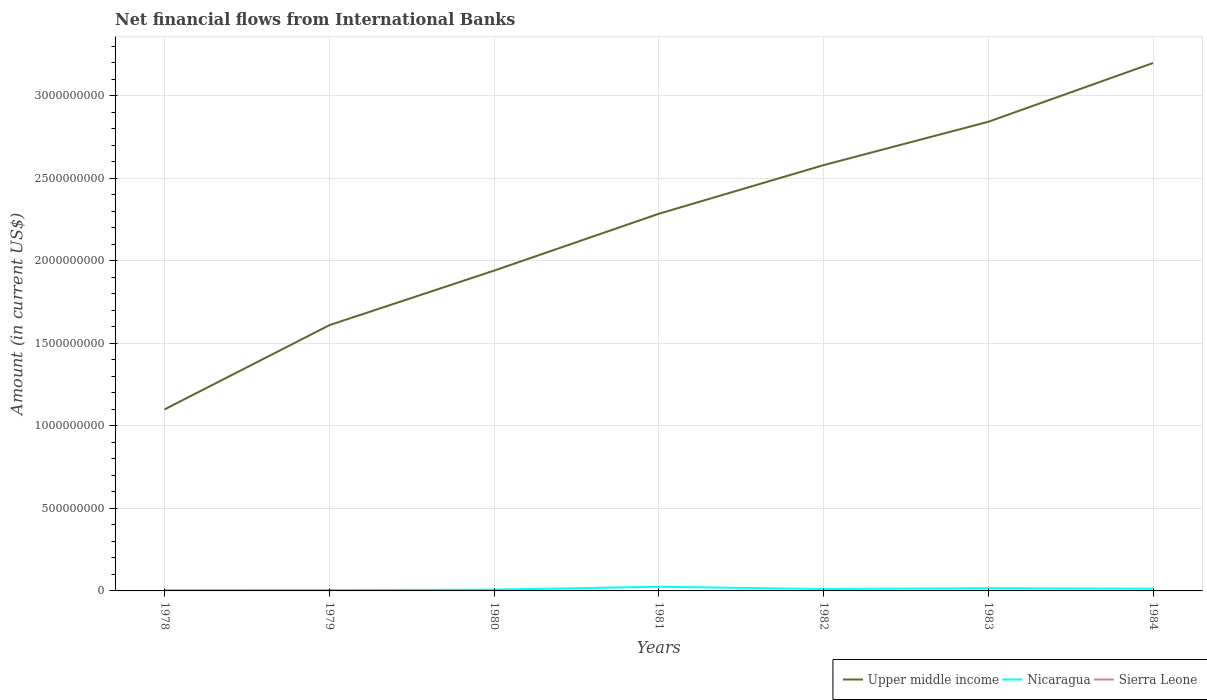Does the line corresponding to Nicaragua intersect with the line corresponding to Sierra Leone?
Make the answer very short. No. Across all years, what is the maximum net financial aid flows in Upper middle income?
Offer a very short reply. 1.10e+09. What is the total net financial aid flows in Upper middle income in the graph?
Give a very brief answer. -1.59e+09. What is the difference between the highest and the second highest net financial aid flows in Upper middle income?
Your response must be concise. 2.10e+09. Is the net financial aid flows in Sierra Leone strictly greater than the net financial aid flows in Nicaragua over the years?
Your answer should be compact. Yes. How many lines are there?
Your answer should be compact. 3. What is the difference between two consecutive major ticks on the Y-axis?
Offer a very short reply. 5.00e+08. Does the graph contain grids?
Offer a terse response. Yes. Where does the legend appear in the graph?
Give a very brief answer. Bottom right. How many legend labels are there?
Provide a succinct answer. 3. How are the legend labels stacked?
Offer a very short reply. Horizontal. What is the title of the graph?
Your answer should be compact. Net financial flows from International Banks. What is the Amount (in current US$) of Upper middle income in 1978?
Provide a succinct answer. 1.10e+09. What is the Amount (in current US$) in Nicaragua in 1978?
Keep it short and to the point. 5.04e+06. What is the Amount (in current US$) of Sierra Leone in 1978?
Provide a short and direct response. 0. What is the Amount (in current US$) of Upper middle income in 1979?
Offer a terse response. 1.61e+09. What is the Amount (in current US$) of Nicaragua in 1979?
Make the answer very short. 4.35e+06. What is the Amount (in current US$) of Sierra Leone in 1979?
Your answer should be very brief. 2.85e+06. What is the Amount (in current US$) of Upper middle income in 1980?
Provide a succinct answer. 1.94e+09. What is the Amount (in current US$) of Nicaragua in 1980?
Keep it short and to the point. 7.92e+06. What is the Amount (in current US$) in Sierra Leone in 1980?
Your answer should be compact. 1.50e+06. What is the Amount (in current US$) in Upper middle income in 1981?
Your answer should be compact. 2.29e+09. What is the Amount (in current US$) in Nicaragua in 1981?
Your response must be concise. 2.52e+07. What is the Amount (in current US$) of Sierra Leone in 1981?
Make the answer very short. 0. What is the Amount (in current US$) in Upper middle income in 1982?
Offer a terse response. 2.58e+09. What is the Amount (in current US$) of Nicaragua in 1982?
Offer a terse response. 1.16e+07. What is the Amount (in current US$) of Upper middle income in 1983?
Your answer should be very brief. 2.84e+09. What is the Amount (in current US$) in Nicaragua in 1983?
Offer a terse response. 1.66e+07. What is the Amount (in current US$) in Sierra Leone in 1983?
Ensure brevity in your answer.  0. What is the Amount (in current US$) of Upper middle income in 1984?
Provide a short and direct response. 3.20e+09. What is the Amount (in current US$) in Nicaragua in 1984?
Make the answer very short. 1.36e+07. Across all years, what is the maximum Amount (in current US$) in Upper middle income?
Make the answer very short. 3.20e+09. Across all years, what is the maximum Amount (in current US$) of Nicaragua?
Offer a very short reply. 2.52e+07. Across all years, what is the maximum Amount (in current US$) in Sierra Leone?
Offer a terse response. 2.85e+06. Across all years, what is the minimum Amount (in current US$) in Upper middle income?
Provide a succinct answer. 1.10e+09. Across all years, what is the minimum Amount (in current US$) of Nicaragua?
Provide a short and direct response. 4.35e+06. What is the total Amount (in current US$) of Upper middle income in the graph?
Make the answer very short. 1.56e+1. What is the total Amount (in current US$) in Nicaragua in the graph?
Your answer should be compact. 8.43e+07. What is the total Amount (in current US$) in Sierra Leone in the graph?
Your answer should be compact. 4.35e+06. What is the difference between the Amount (in current US$) in Upper middle income in 1978 and that in 1979?
Keep it short and to the point. -5.10e+08. What is the difference between the Amount (in current US$) of Nicaragua in 1978 and that in 1979?
Provide a succinct answer. 6.92e+05. What is the difference between the Amount (in current US$) of Upper middle income in 1978 and that in 1980?
Your response must be concise. -8.41e+08. What is the difference between the Amount (in current US$) in Nicaragua in 1978 and that in 1980?
Make the answer very short. -2.87e+06. What is the difference between the Amount (in current US$) of Upper middle income in 1978 and that in 1981?
Ensure brevity in your answer.  -1.19e+09. What is the difference between the Amount (in current US$) of Nicaragua in 1978 and that in 1981?
Your answer should be very brief. -2.01e+07. What is the difference between the Amount (in current US$) of Upper middle income in 1978 and that in 1982?
Offer a terse response. -1.48e+09. What is the difference between the Amount (in current US$) in Nicaragua in 1978 and that in 1982?
Your answer should be very brief. -6.56e+06. What is the difference between the Amount (in current US$) of Upper middle income in 1978 and that in 1983?
Give a very brief answer. -1.74e+09. What is the difference between the Amount (in current US$) in Nicaragua in 1978 and that in 1983?
Give a very brief answer. -1.16e+07. What is the difference between the Amount (in current US$) in Upper middle income in 1978 and that in 1984?
Ensure brevity in your answer.  -2.10e+09. What is the difference between the Amount (in current US$) of Nicaragua in 1978 and that in 1984?
Offer a terse response. -8.55e+06. What is the difference between the Amount (in current US$) of Upper middle income in 1979 and that in 1980?
Provide a short and direct response. -3.31e+08. What is the difference between the Amount (in current US$) in Nicaragua in 1979 and that in 1980?
Your response must be concise. -3.57e+06. What is the difference between the Amount (in current US$) of Sierra Leone in 1979 and that in 1980?
Ensure brevity in your answer.  1.35e+06. What is the difference between the Amount (in current US$) in Upper middle income in 1979 and that in 1981?
Your response must be concise. -6.75e+08. What is the difference between the Amount (in current US$) in Nicaragua in 1979 and that in 1981?
Provide a short and direct response. -2.08e+07. What is the difference between the Amount (in current US$) of Upper middle income in 1979 and that in 1982?
Give a very brief answer. -9.70e+08. What is the difference between the Amount (in current US$) in Nicaragua in 1979 and that in 1982?
Give a very brief answer. -7.26e+06. What is the difference between the Amount (in current US$) of Upper middle income in 1979 and that in 1983?
Keep it short and to the point. -1.23e+09. What is the difference between the Amount (in current US$) in Nicaragua in 1979 and that in 1983?
Provide a short and direct response. -1.23e+07. What is the difference between the Amount (in current US$) of Upper middle income in 1979 and that in 1984?
Provide a short and direct response. -1.59e+09. What is the difference between the Amount (in current US$) in Nicaragua in 1979 and that in 1984?
Keep it short and to the point. -9.24e+06. What is the difference between the Amount (in current US$) in Upper middle income in 1980 and that in 1981?
Ensure brevity in your answer.  -3.45e+08. What is the difference between the Amount (in current US$) of Nicaragua in 1980 and that in 1981?
Offer a terse response. -1.72e+07. What is the difference between the Amount (in current US$) of Upper middle income in 1980 and that in 1982?
Ensure brevity in your answer.  -6.39e+08. What is the difference between the Amount (in current US$) in Nicaragua in 1980 and that in 1982?
Your response must be concise. -3.69e+06. What is the difference between the Amount (in current US$) of Upper middle income in 1980 and that in 1983?
Keep it short and to the point. -9.02e+08. What is the difference between the Amount (in current US$) of Nicaragua in 1980 and that in 1983?
Your answer should be compact. -8.73e+06. What is the difference between the Amount (in current US$) of Upper middle income in 1980 and that in 1984?
Provide a short and direct response. -1.26e+09. What is the difference between the Amount (in current US$) in Nicaragua in 1980 and that in 1984?
Make the answer very short. -5.67e+06. What is the difference between the Amount (in current US$) in Upper middle income in 1981 and that in 1982?
Offer a terse response. -2.95e+08. What is the difference between the Amount (in current US$) in Nicaragua in 1981 and that in 1982?
Offer a terse response. 1.35e+07. What is the difference between the Amount (in current US$) in Upper middle income in 1981 and that in 1983?
Keep it short and to the point. -5.57e+08. What is the difference between the Amount (in current US$) in Nicaragua in 1981 and that in 1983?
Provide a short and direct response. 8.51e+06. What is the difference between the Amount (in current US$) of Upper middle income in 1981 and that in 1984?
Provide a short and direct response. -9.14e+08. What is the difference between the Amount (in current US$) in Nicaragua in 1981 and that in 1984?
Make the answer very short. 1.16e+07. What is the difference between the Amount (in current US$) of Upper middle income in 1982 and that in 1983?
Provide a short and direct response. -2.63e+08. What is the difference between the Amount (in current US$) in Nicaragua in 1982 and that in 1983?
Your answer should be compact. -5.04e+06. What is the difference between the Amount (in current US$) in Upper middle income in 1982 and that in 1984?
Keep it short and to the point. -6.19e+08. What is the difference between the Amount (in current US$) of Nicaragua in 1982 and that in 1984?
Make the answer very short. -1.98e+06. What is the difference between the Amount (in current US$) in Upper middle income in 1983 and that in 1984?
Provide a short and direct response. -3.56e+08. What is the difference between the Amount (in current US$) of Nicaragua in 1983 and that in 1984?
Your response must be concise. 3.05e+06. What is the difference between the Amount (in current US$) in Upper middle income in 1978 and the Amount (in current US$) in Nicaragua in 1979?
Give a very brief answer. 1.10e+09. What is the difference between the Amount (in current US$) in Upper middle income in 1978 and the Amount (in current US$) in Sierra Leone in 1979?
Offer a terse response. 1.10e+09. What is the difference between the Amount (in current US$) of Nicaragua in 1978 and the Amount (in current US$) of Sierra Leone in 1979?
Provide a succinct answer. 2.19e+06. What is the difference between the Amount (in current US$) of Upper middle income in 1978 and the Amount (in current US$) of Nicaragua in 1980?
Your response must be concise. 1.09e+09. What is the difference between the Amount (in current US$) in Upper middle income in 1978 and the Amount (in current US$) in Sierra Leone in 1980?
Your answer should be very brief. 1.10e+09. What is the difference between the Amount (in current US$) of Nicaragua in 1978 and the Amount (in current US$) of Sierra Leone in 1980?
Provide a short and direct response. 3.54e+06. What is the difference between the Amount (in current US$) in Upper middle income in 1978 and the Amount (in current US$) in Nicaragua in 1981?
Keep it short and to the point. 1.07e+09. What is the difference between the Amount (in current US$) in Upper middle income in 1978 and the Amount (in current US$) in Nicaragua in 1982?
Keep it short and to the point. 1.09e+09. What is the difference between the Amount (in current US$) in Upper middle income in 1978 and the Amount (in current US$) in Nicaragua in 1983?
Provide a short and direct response. 1.08e+09. What is the difference between the Amount (in current US$) in Upper middle income in 1978 and the Amount (in current US$) in Nicaragua in 1984?
Your answer should be very brief. 1.09e+09. What is the difference between the Amount (in current US$) of Upper middle income in 1979 and the Amount (in current US$) of Nicaragua in 1980?
Your response must be concise. 1.60e+09. What is the difference between the Amount (in current US$) in Upper middle income in 1979 and the Amount (in current US$) in Sierra Leone in 1980?
Offer a very short reply. 1.61e+09. What is the difference between the Amount (in current US$) in Nicaragua in 1979 and the Amount (in current US$) in Sierra Leone in 1980?
Your response must be concise. 2.85e+06. What is the difference between the Amount (in current US$) of Upper middle income in 1979 and the Amount (in current US$) of Nicaragua in 1981?
Provide a short and direct response. 1.59e+09. What is the difference between the Amount (in current US$) in Upper middle income in 1979 and the Amount (in current US$) in Nicaragua in 1982?
Make the answer very short. 1.60e+09. What is the difference between the Amount (in current US$) of Upper middle income in 1979 and the Amount (in current US$) of Nicaragua in 1983?
Provide a short and direct response. 1.59e+09. What is the difference between the Amount (in current US$) in Upper middle income in 1979 and the Amount (in current US$) in Nicaragua in 1984?
Ensure brevity in your answer.  1.60e+09. What is the difference between the Amount (in current US$) of Upper middle income in 1980 and the Amount (in current US$) of Nicaragua in 1981?
Ensure brevity in your answer.  1.92e+09. What is the difference between the Amount (in current US$) in Upper middle income in 1980 and the Amount (in current US$) in Nicaragua in 1982?
Keep it short and to the point. 1.93e+09. What is the difference between the Amount (in current US$) in Upper middle income in 1980 and the Amount (in current US$) in Nicaragua in 1983?
Your answer should be very brief. 1.92e+09. What is the difference between the Amount (in current US$) in Upper middle income in 1980 and the Amount (in current US$) in Nicaragua in 1984?
Offer a terse response. 1.93e+09. What is the difference between the Amount (in current US$) of Upper middle income in 1981 and the Amount (in current US$) of Nicaragua in 1982?
Your answer should be compact. 2.27e+09. What is the difference between the Amount (in current US$) of Upper middle income in 1981 and the Amount (in current US$) of Nicaragua in 1983?
Make the answer very short. 2.27e+09. What is the difference between the Amount (in current US$) in Upper middle income in 1981 and the Amount (in current US$) in Nicaragua in 1984?
Your answer should be compact. 2.27e+09. What is the difference between the Amount (in current US$) in Upper middle income in 1982 and the Amount (in current US$) in Nicaragua in 1983?
Provide a succinct answer. 2.56e+09. What is the difference between the Amount (in current US$) in Upper middle income in 1982 and the Amount (in current US$) in Nicaragua in 1984?
Your answer should be very brief. 2.57e+09. What is the difference between the Amount (in current US$) of Upper middle income in 1983 and the Amount (in current US$) of Nicaragua in 1984?
Provide a short and direct response. 2.83e+09. What is the average Amount (in current US$) of Upper middle income per year?
Your answer should be compact. 2.22e+09. What is the average Amount (in current US$) in Nicaragua per year?
Offer a very short reply. 1.20e+07. What is the average Amount (in current US$) in Sierra Leone per year?
Give a very brief answer. 6.22e+05. In the year 1978, what is the difference between the Amount (in current US$) of Upper middle income and Amount (in current US$) of Nicaragua?
Offer a very short reply. 1.10e+09. In the year 1979, what is the difference between the Amount (in current US$) of Upper middle income and Amount (in current US$) of Nicaragua?
Your answer should be compact. 1.61e+09. In the year 1979, what is the difference between the Amount (in current US$) of Upper middle income and Amount (in current US$) of Sierra Leone?
Offer a terse response. 1.61e+09. In the year 1979, what is the difference between the Amount (in current US$) in Nicaragua and Amount (in current US$) in Sierra Leone?
Offer a very short reply. 1.50e+06. In the year 1980, what is the difference between the Amount (in current US$) of Upper middle income and Amount (in current US$) of Nicaragua?
Your response must be concise. 1.93e+09. In the year 1980, what is the difference between the Amount (in current US$) of Upper middle income and Amount (in current US$) of Sierra Leone?
Keep it short and to the point. 1.94e+09. In the year 1980, what is the difference between the Amount (in current US$) in Nicaragua and Amount (in current US$) in Sierra Leone?
Your answer should be very brief. 6.42e+06. In the year 1981, what is the difference between the Amount (in current US$) of Upper middle income and Amount (in current US$) of Nicaragua?
Offer a very short reply. 2.26e+09. In the year 1982, what is the difference between the Amount (in current US$) in Upper middle income and Amount (in current US$) in Nicaragua?
Your answer should be compact. 2.57e+09. In the year 1983, what is the difference between the Amount (in current US$) in Upper middle income and Amount (in current US$) in Nicaragua?
Your answer should be compact. 2.83e+09. In the year 1984, what is the difference between the Amount (in current US$) in Upper middle income and Amount (in current US$) in Nicaragua?
Provide a succinct answer. 3.19e+09. What is the ratio of the Amount (in current US$) of Upper middle income in 1978 to that in 1979?
Provide a succinct answer. 0.68. What is the ratio of the Amount (in current US$) in Nicaragua in 1978 to that in 1979?
Offer a very short reply. 1.16. What is the ratio of the Amount (in current US$) of Upper middle income in 1978 to that in 1980?
Your answer should be compact. 0.57. What is the ratio of the Amount (in current US$) of Nicaragua in 1978 to that in 1980?
Give a very brief answer. 0.64. What is the ratio of the Amount (in current US$) of Upper middle income in 1978 to that in 1981?
Provide a short and direct response. 0.48. What is the ratio of the Amount (in current US$) in Nicaragua in 1978 to that in 1981?
Provide a short and direct response. 0.2. What is the ratio of the Amount (in current US$) in Upper middle income in 1978 to that in 1982?
Provide a short and direct response. 0.43. What is the ratio of the Amount (in current US$) in Nicaragua in 1978 to that in 1982?
Keep it short and to the point. 0.43. What is the ratio of the Amount (in current US$) of Upper middle income in 1978 to that in 1983?
Keep it short and to the point. 0.39. What is the ratio of the Amount (in current US$) of Nicaragua in 1978 to that in 1983?
Keep it short and to the point. 0.3. What is the ratio of the Amount (in current US$) of Upper middle income in 1978 to that in 1984?
Offer a terse response. 0.34. What is the ratio of the Amount (in current US$) in Nicaragua in 1978 to that in 1984?
Keep it short and to the point. 0.37. What is the ratio of the Amount (in current US$) of Upper middle income in 1979 to that in 1980?
Give a very brief answer. 0.83. What is the ratio of the Amount (in current US$) in Nicaragua in 1979 to that in 1980?
Your answer should be compact. 0.55. What is the ratio of the Amount (in current US$) of Sierra Leone in 1979 to that in 1980?
Keep it short and to the point. 1.9. What is the ratio of the Amount (in current US$) of Upper middle income in 1979 to that in 1981?
Give a very brief answer. 0.7. What is the ratio of the Amount (in current US$) in Nicaragua in 1979 to that in 1981?
Make the answer very short. 0.17. What is the ratio of the Amount (in current US$) of Upper middle income in 1979 to that in 1982?
Provide a short and direct response. 0.62. What is the ratio of the Amount (in current US$) in Nicaragua in 1979 to that in 1982?
Provide a short and direct response. 0.37. What is the ratio of the Amount (in current US$) in Upper middle income in 1979 to that in 1983?
Ensure brevity in your answer.  0.57. What is the ratio of the Amount (in current US$) of Nicaragua in 1979 to that in 1983?
Offer a very short reply. 0.26. What is the ratio of the Amount (in current US$) of Upper middle income in 1979 to that in 1984?
Give a very brief answer. 0.5. What is the ratio of the Amount (in current US$) in Nicaragua in 1979 to that in 1984?
Offer a very short reply. 0.32. What is the ratio of the Amount (in current US$) in Upper middle income in 1980 to that in 1981?
Your response must be concise. 0.85. What is the ratio of the Amount (in current US$) in Nicaragua in 1980 to that in 1981?
Keep it short and to the point. 0.31. What is the ratio of the Amount (in current US$) in Upper middle income in 1980 to that in 1982?
Provide a short and direct response. 0.75. What is the ratio of the Amount (in current US$) in Nicaragua in 1980 to that in 1982?
Make the answer very short. 0.68. What is the ratio of the Amount (in current US$) of Upper middle income in 1980 to that in 1983?
Your answer should be compact. 0.68. What is the ratio of the Amount (in current US$) of Nicaragua in 1980 to that in 1983?
Ensure brevity in your answer.  0.48. What is the ratio of the Amount (in current US$) in Upper middle income in 1980 to that in 1984?
Offer a terse response. 0.61. What is the ratio of the Amount (in current US$) in Nicaragua in 1980 to that in 1984?
Keep it short and to the point. 0.58. What is the ratio of the Amount (in current US$) of Upper middle income in 1981 to that in 1982?
Make the answer very short. 0.89. What is the ratio of the Amount (in current US$) in Nicaragua in 1981 to that in 1982?
Ensure brevity in your answer.  2.17. What is the ratio of the Amount (in current US$) in Upper middle income in 1981 to that in 1983?
Ensure brevity in your answer.  0.8. What is the ratio of the Amount (in current US$) in Nicaragua in 1981 to that in 1983?
Offer a terse response. 1.51. What is the ratio of the Amount (in current US$) of Upper middle income in 1981 to that in 1984?
Keep it short and to the point. 0.71. What is the ratio of the Amount (in current US$) in Nicaragua in 1981 to that in 1984?
Give a very brief answer. 1.85. What is the ratio of the Amount (in current US$) in Upper middle income in 1982 to that in 1983?
Provide a succinct answer. 0.91. What is the ratio of the Amount (in current US$) in Nicaragua in 1982 to that in 1983?
Your answer should be compact. 0.7. What is the ratio of the Amount (in current US$) of Upper middle income in 1982 to that in 1984?
Your answer should be compact. 0.81. What is the ratio of the Amount (in current US$) in Nicaragua in 1982 to that in 1984?
Your answer should be compact. 0.85. What is the ratio of the Amount (in current US$) in Upper middle income in 1983 to that in 1984?
Make the answer very short. 0.89. What is the ratio of the Amount (in current US$) of Nicaragua in 1983 to that in 1984?
Your answer should be very brief. 1.22. What is the difference between the highest and the second highest Amount (in current US$) of Upper middle income?
Your response must be concise. 3.56e+08. What is the difference between the highest and the second highest Amount (in current US$) of Nicaragua?
Keep it short and to the point. 8.51e+06. What is the difference between the highest and the lowest Amount (in current US$) in Upper middle income?
Make the answer very short. 2.10e+09. What is the difference between the highest and the lowest Amount (in current US$) in Nicaragua?
Your answer should be compact. 2.08e+07. What is the difference between the highest and the lowest Amount (in current US$) in Sierra Leone?
Give a very brief answer. 2.85e+06. 